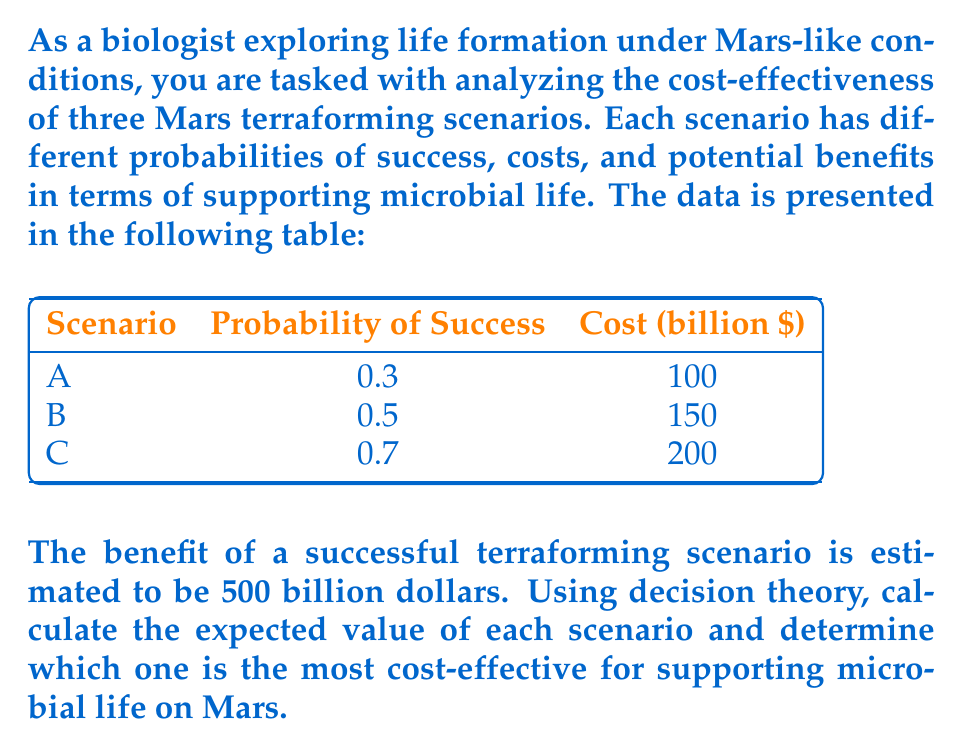What is the answer to this math problem? To solve this problem, we need to calculate the expected value for each scenario and compare them. The expected value is calculated by subtracting the cost from the product of the probability of success and the benefit.

Let's calculate the expected value for each scenario:

1. Scenario A:
   Expected Value = (Probability × Benefit) - Cost
   $EV_A = (0.3 \times \$500 \text{ billion}) - \$100 \text{ billion}$
   $EV_A = \$150 \text{ billion} - \$100 \text{ billion} = \$50 \text{ billion}$

2. Scenario B:
   $EV_B = (0.5 \times \$500 \text{ billion}) - \$150 \text{ billion}$
   $EV_B = \$250 \text{ billion} - \$150 \text{ billion} = \$100 \text{ billion}$

3. Scenario C:
   $EV_C = (0.7 \times \$500 \text{ billion}) - \$200 \text{ billion}$
   $EV_C = \$350 \text{ billion} - \$200 \text{ billion} = \$150 \text{ billion}$

Now, let's compare the expected values:
$EV_A = \$50 \text{ billion}$
$EV_B = \$100 \text{ billion}$
$EV_C = \$150 \text{ billion}$

The scenario with the highest expected value is the most cost-effective. In this case, Scenario C has the highest expected value of $150 billion.
Answer: Scenario C 